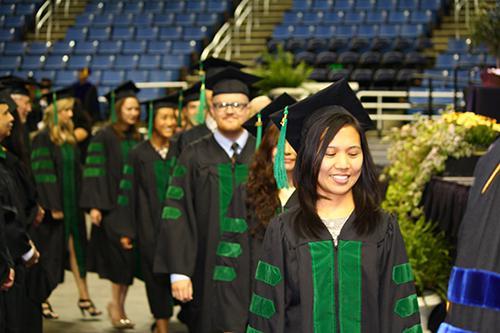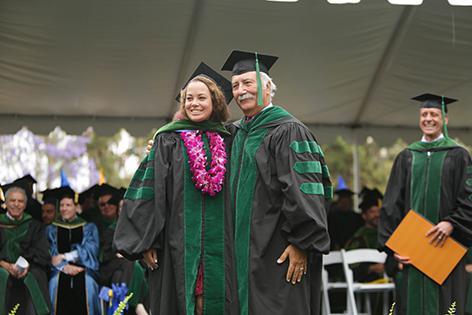The first image is the image on the left, the second image is the image on the right. Assess this claim about the two images: "Blue seats are shown in the auditorium behind the graduates in one of the images.". Correct or not? Answer yes or no. Yes. The first image is the image on the left, the second image is the image on the right. Analyze the images presented: Is the assertion "In one image, graduates are walking forward wearing black robes with green sleeve stripes and caps with green tassles." valid? Answer yes or no. Yes. 